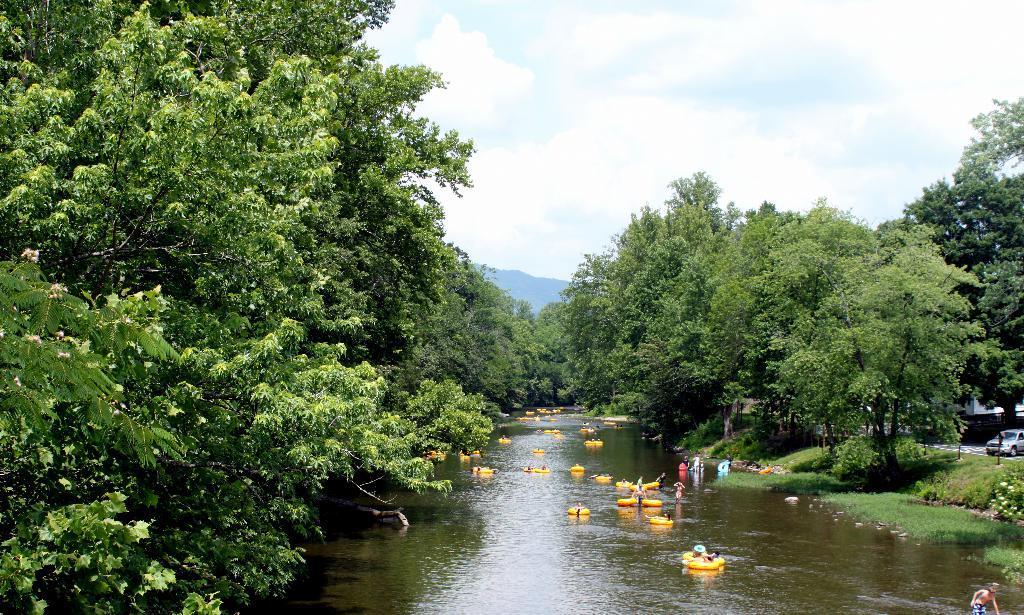What type of watercraft can be seen in the canal? There are lifeboats in the canal. What type of vegetation is present on either side of the canal? Trees are present on either side of the canal. What geographical feature is visible in the background? There is a mountain visible in the background. What part of the natural environment is visible in the image? The sky is visible in the image. What atmospheric conditions can be observed in the sky? Clouds are present in the sky. What type of suit is being worn by the trees on either side of the canal? There are no suits present in the image; the trees are not wearing any clothing. How does the comb help the mountain in the background? There is no comb present in the image, and the mountain does not require assistance from a comb. 